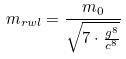Convert formula to latex. <formula><loc_0><loc_0><loc_500><loc_500>m _ { r w l } = \frac { m _ { 0 } } { \sqrt { 7 \cdot \frac { g ^ { 8 } } { c ^ { 8 } } } }</formula> 